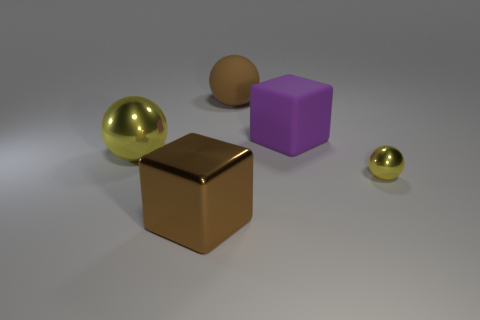Subtract 1 balls. How many balls are left? 2 Add 5 big matte blocks. How many objects exist? 10 Subtract all cubes. How many objects are left? 3 Subtract 0 green cylinders. How many objects are left? 5 Subtract all tiny purple metallic cubes. Subtract all large brown shiny objects. How many objects are left? 4 Add 2 yellow shiny objects. How many yellow shiny objects are left? 4 Add 3 big brown things. How many big brown things exist? 5 